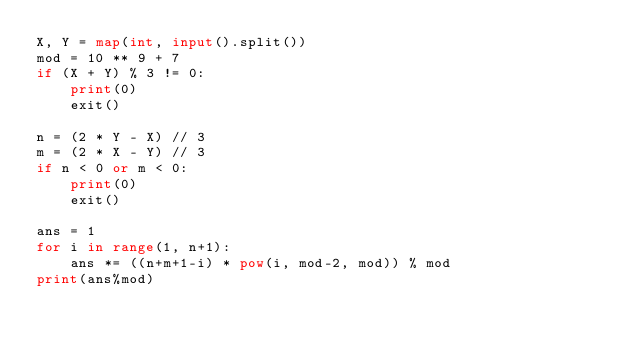<code> <loc_0><loc_0><loc_500><loc_500><_Python_>X, Y = map(int, input().split())
mod = 10 ** 9 + 7
if (X + Y) % 3 != 0:
    print(0)
    exit()
    
n = (2 * Y - X) // 3
m = (2 * X - Y) // 3
if n < 0 or m < 0:
    print(0)
    exit()    

ans = 1
for i in range(1, n+1):
    ans *= ((n+m+1-i) * pow(i, mod-2, mod)) % mod
print(ans%mod)</code> 